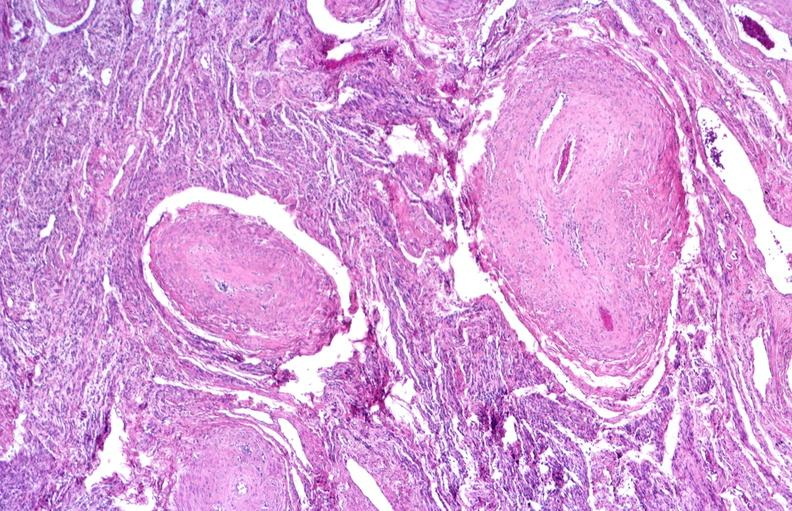what does this image show?
Answer the question using a single word or phrase. Kidney 